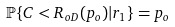<formula> <loc_0><loc_0><loc_500><loc_500>\mathbb { P } \{ C < R _ { o D } ( p _ { o } ) | r _ { 1 } \} & = p _ { o } & &</formula> 